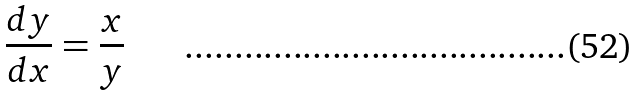<formula> <loc_0><loc_0><loc_500><loc_500>\frac { d y } { d x } = \frac { x } { y }</formula> 